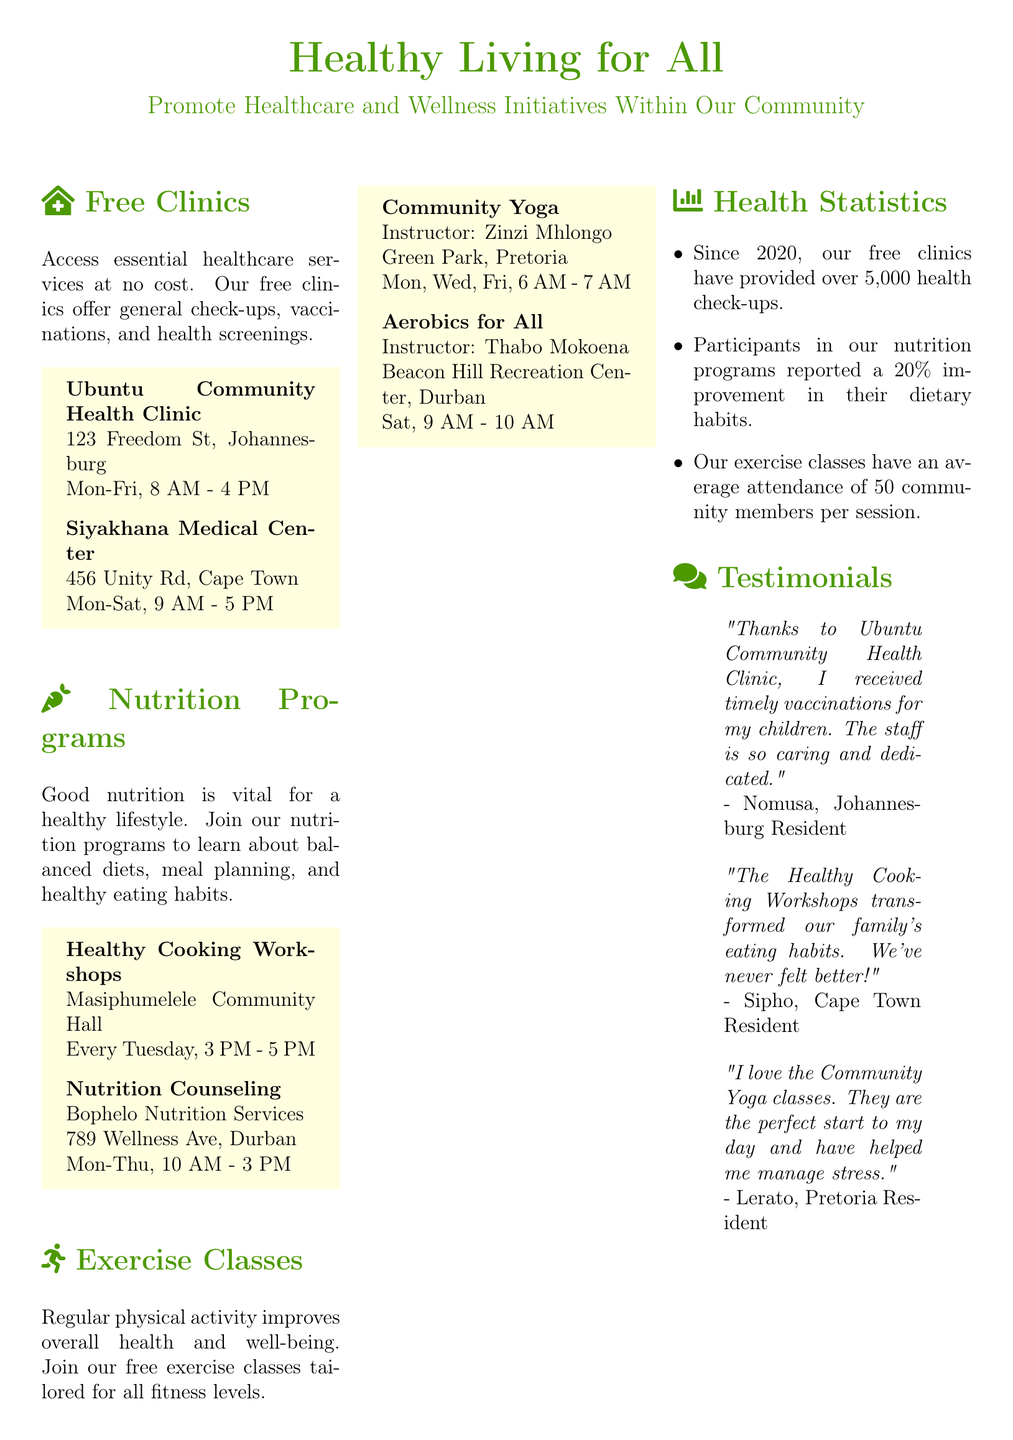What is the name of the free clinic in Johannesburg? The name of the free clinic in Johannesburg is mentioned in the document as the Ubuntu Community Health Clinic.
Answer: Ubuntu Community Health Clinic What are the operating days of the Siyakhana Medical Center? The document provides the operational information indicating that the Siyakhana Medical Center is open from Monday to Saturday.
Answer: Mon-Sat How many health check-ups have been provided since 2020? The document states that over 5,000 health check-ups have been provided by the free clinics since 2020.
Answer: 5,000 What time do the Healthy Cooking Workshops start? The document specifies that the Healthy Cooking Workshops start at 3 PM every Tuesday.
Answer: 3 PM Who is the instructor for the Community Yoga classes? The document provides the instructor's name for the Community Yoga classes, which is Zinzi Mhlongo.
Answer: Zinzi Mhlongo What is the average attendance for exercise classes? The document mentions that the average attendance for exercise classes is 50 community members per session.
Answer: 50 Where are the nutrition counseling services located? The document states that the nutrition counseling services are provided by Bophelo Nutrition Services located at 789 Wellness Ave, Durban.
Answer: 789 Wellness Ave, Durban What is the main focus of the flyer? The document clearly outlines that the main focus is to promote healthcare and wellness initiatives within the community.
Answer: Promote Healthcare and Wellness Initiatives How many days per week does Community Yoga occur? The document indicates that Community Yoga classes occur three days a week.
Answer: Three days What is the contact email for more information? The document lists the contact email for more information as healthyliving@community.org.
Answer: healthyliving@community.org 